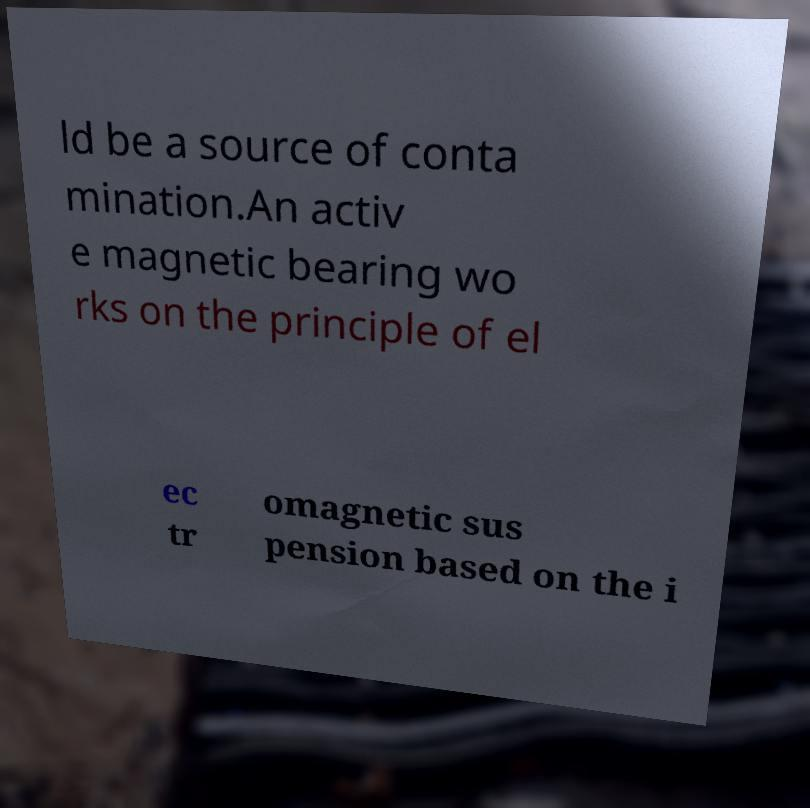Can you read and provide the text displayed in the image?This photo seems to have some interesting text. Can you extract and type it out for me? ld be a source of conta mination.An activ e magnetic bearing wo rks on the principle of el ec tr omagnetic sus pension based on the i 